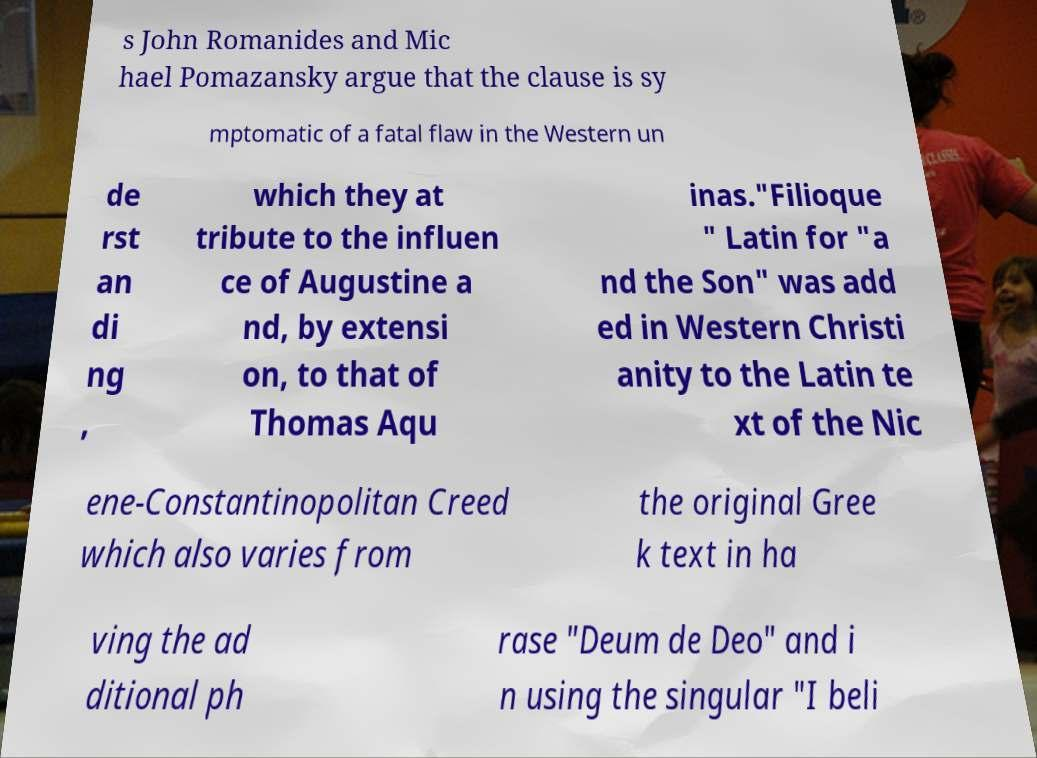Could you assist in decoding the text presented in this image and type it out clearly? s John Romanides and Mic hael Pomazansky argue that the clause is sy mptomatic of a fatal flaw in the Western un de rst an di ng , which they at tribute to the influen ce of Augustine a nd, by extensi on, to that of Thomas Aqu inas."Filioque " Latin for "a nd the Son" was add ed in Western Christi anity to the Latin te xt of the Nic ene-Constantinopolitan Creed which also varies from the original Gree k text in ha ving the ad ditional ph rase "Deum de Deo" and i n using the singular "I beli 